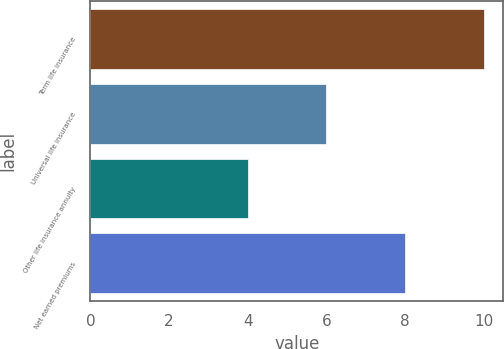Convert chart. <chart><loc_0><loc_0><loc_500><loc_500><bar_chart><fcel>Term life insurance<fcel>Universal life insurance<fcel>Other life insurance annuity<fcel>Net earned premiums<nl><fcel>10<fcel>6<fcel>4<fcel>8<nl></chart> 